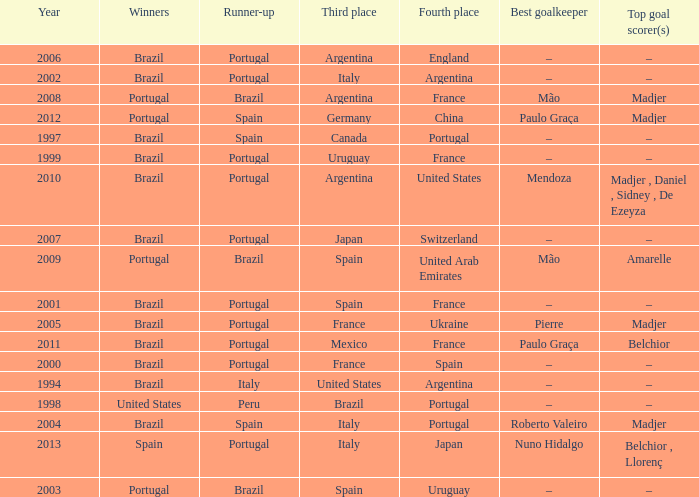What year was the runner-up Portugal with Italy in third place, and the gold keeper Nuno Hidalgo? 2013.0. 